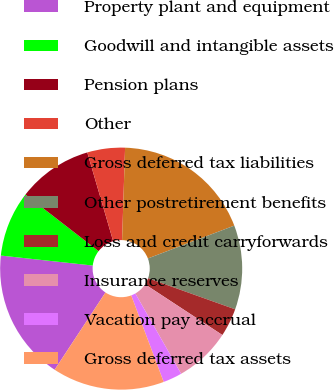<chart> <loc_0><loc_0><loc_500><loc_500><pie_chart><fcel>Property plant and equipment<fcel>Goodwill and intangible assets<fcel>Pension plans<fcel>Other<fcel>Gross deferred tax liabilities<fcel>Other postretirement benefits<fcel>Loss and credit carryforwards<fcel>Insurance reserves<fcel>Vacation pay accrual<fcel>Gross deferred tax assets<nl><fcel>17.46%<fcel>8.76%<fcel>10.0%<fcel>5.03%<fcel>18.7%<fcel>11.24%<fcel>3.78%<fcel>7.51%<fcel>2.54%<fcel>14.97%<nl></chart> 